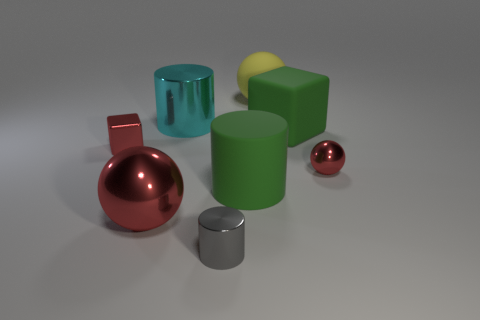Add 2 red shiny cylinders. How many objects exist? 10 Subtract all spheres. How many objects are left? 5 Add 1 red objects. How many red objects exist? 4 Subtract 0 brown blocks. How many objects are left? 8 Subtract all big cyan metal cylinders. Subtract all red things. How many objects are left? 4 Add 3 metallic cylinders. How many metallic cylinders are left? 5 